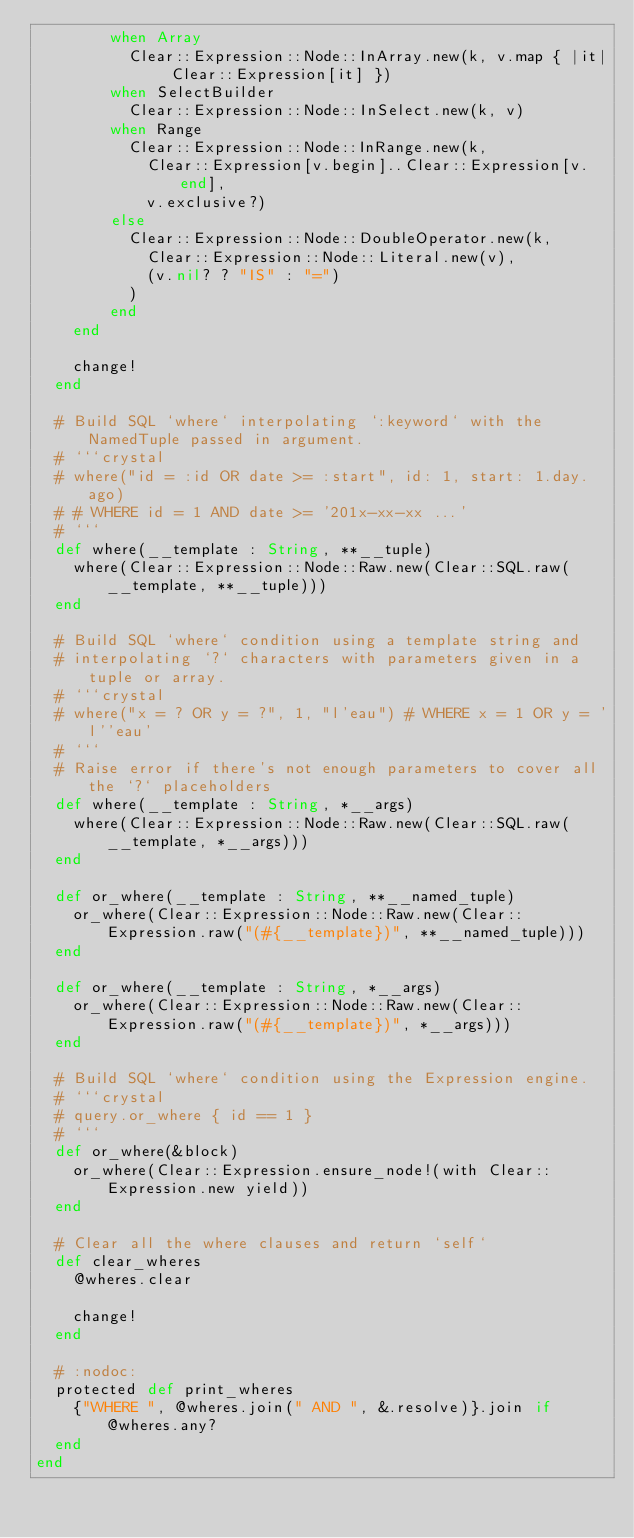Convert code to text. <code><loc_0><loc_0><loc_500><loc_500><_Crystal_>        when Array
          Clear::Expression::Node::InArray.new(k, v.map { |it| Clear::Expression[it] })
        when SelectBuilder
          Clear::Expression::Node::InSelect.new(k, v)
        when Range
          Clear::Expression::Node::InRange.new(k,
            Clear::Expression[v.begin]..Clear::Expression[v.end],
            v.exclusive?)
        else
          Clear::Expression::Node::DoubleOperator.new(k,
            Clear::Expression::Node::Literal.new(v),
            (v.nil? ? "IS" : "=")
          )
        end
    end

    change!
  end

  # Build SQL `where` interpolating `:keyword` with the NamedTuple passed in argument.
  # ```crystal
  # where("id = :id OR date >= :start", id: 1, start: 1.day.ago)
  # # WHERE id = 1 AND date >= '201x-xx-xx ...'
  # ```
  def where(__template : String, **__tuple)
    where(Clear::Expression::Node::Raw.new(Clear::SQL.raw(__template, **__tuple)))
  end

  # Build SQL `where` condition using a template string and
  # interpolating `?` characters with parameters given in a tuple or array.
  # ```crystal
  # where("x = ? OR y = ?", 1, "l'eau") # WHERE x = 1 OR y = 'l''eau'
  # ```
  # Raise error if there's not enough parameters to cover all the `?` placeholders
  def where(__template : String, *__args)
    where(Clear::Expression::Node::Raw.new(Clear::SQL.raw(__template, *__args)))
  end

  def or_where(__template : String, **__named_tuple)
    or_where(Clear::Expression::Node::Raw.new(Clear::Expression.raw("(#{__template})", **__named_tuple)))
  end

  def or_where(__template : String, *__args)
    or_where(Clear::Expression::Node::Raw.new(Clear::Expression.raw("(#{__template})", *__args)))
  end

  # Build SQL `where` condition using the Expression engine.
  # ```crystal
  # query.or_where { id == 1 }
  # ```
  def or_where(&block)
    or_where(Clear::Expression.ensure_node!(with Clear::Expression.new yield))
  end

  # Clear all the where clauses and return `self`
  def clear_wheres
    @wheres.clear

    change!
  end

  # :nodoc:
  protected def print_wheres
    {"WHERE ", @wheres.join(" AND ", &.resolve)}.join if @wheres.any?
  end
end
</code> 